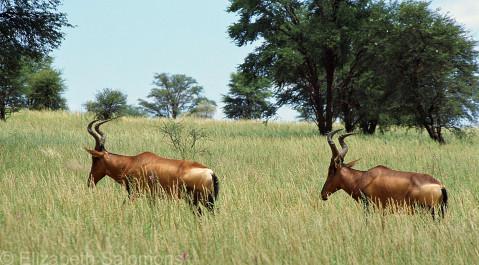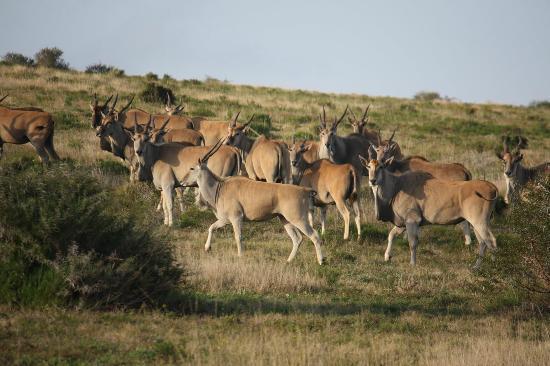The first image is the image on the left, the second image is the image on the right. Examine the images to the left and right. Is the description "There are more hooved, horned animals on the right than on the left." accurate? Answer yes or no. Yes. The first image is the image on the left, the second image is the image on the right. Considering the images on both sides, is "There are exactly two animals in the image on the left." valid? Answer yes or no. Yes. 